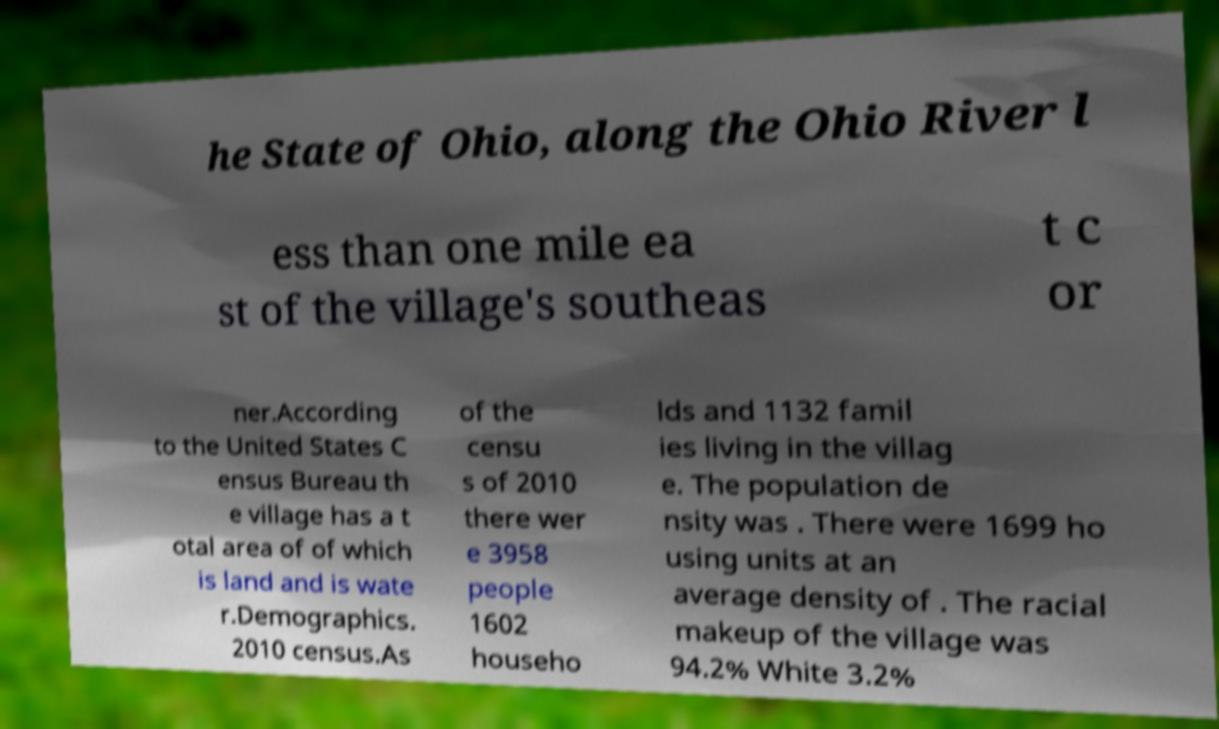What messages or text are displayed in this image? I need them in a readable, typed format. he State of Ohio, along the Ohio River l ess than one mile ea st of the village's southeas t c or ner.According to the United States C ensus Bureau th e village has a t otal area of of which is land and is wate r.Demographics. 2010 census.As of the censu s of 2010 there wer e 3958 people 1602 househo lds and 1132 famil ies living in the villag e. The population de nsity was . There were 1699 ho using units at an average density of . The racial makeup of the village was 94.2% White 3.2% 